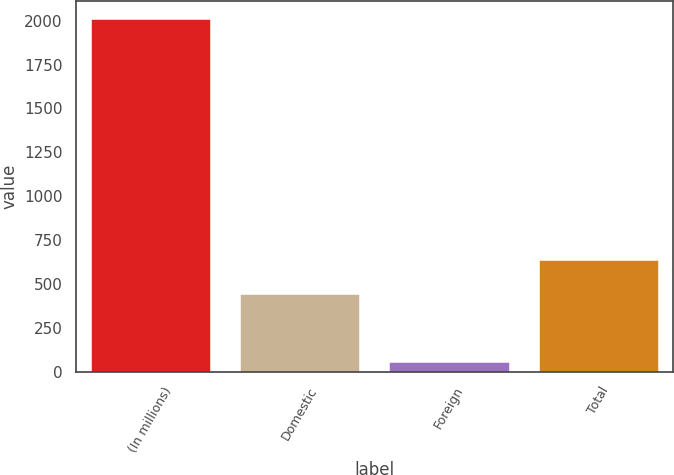<chart> <loc_0><loc_0><loc_500><loc_500><bar_chart><fcel>(In millions)<fcel>Domestic<fcel>Foreign<fcel>Total<nl><fcel>2011<fcel>441.1<fcel>53.5<fcel>636.85<nl></chart> 